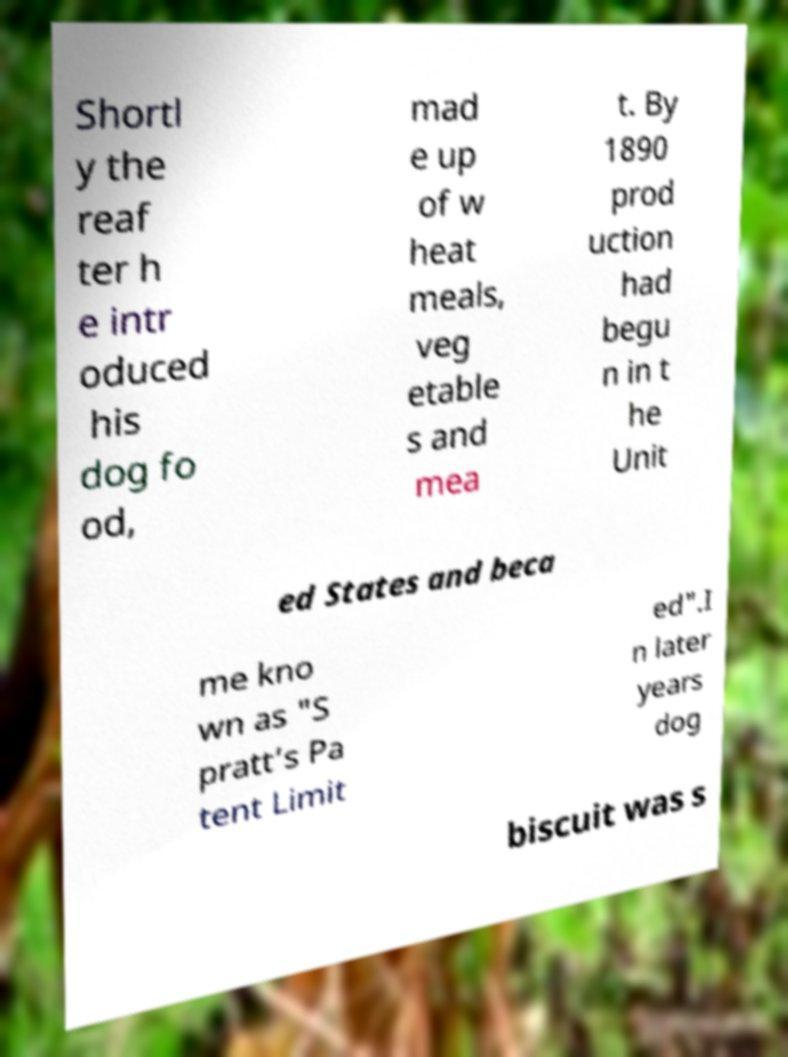Can you accurately transcribe the text from the provided image for me? Shortl y the reaf ter h e intr oduced his dog fo od, mad e up of w heat meals, veg etable s and mea t. By 1890 prod uction had begu n in t he Unit ed States and beca me kno wn as "S pratt’s Pa tent Limit ed".I n later years dog biscuit was s 